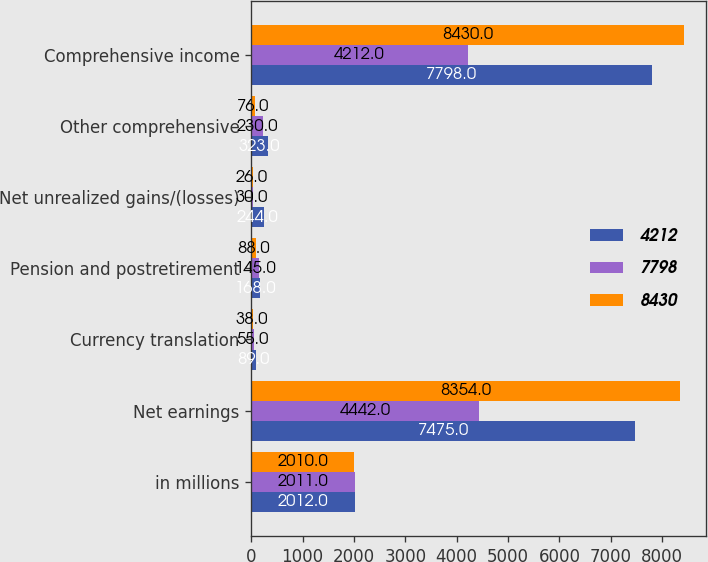Convert chart. <chart><loc_0><loc_0><loc_500><loc_500><stacked_bar_chart><ecel><fcel>in millions<fcel>Net earnings<fcel>Currency translation<fcel>Pension and postretirement<fcel>Net unrealized gains/(losses)<fcel>Other comprehensive<fcel>Comprehensive income<nl><fcel>4212<fcel>2012<fcel>7475<fcel>89<fcel>168<fcel>244<fcel>323<fcel>7798<nl><fcel>7798<fcel>2011<fcel>4442<fcel>55<fcel>145<fcel>30<fcel>230<fcel>4212<nl><fcel>8430<fcel>2010<fcel>8354<fcel>38<fcel>88<fcel>26<fcel>76<fcel>8430<nl></chart> 